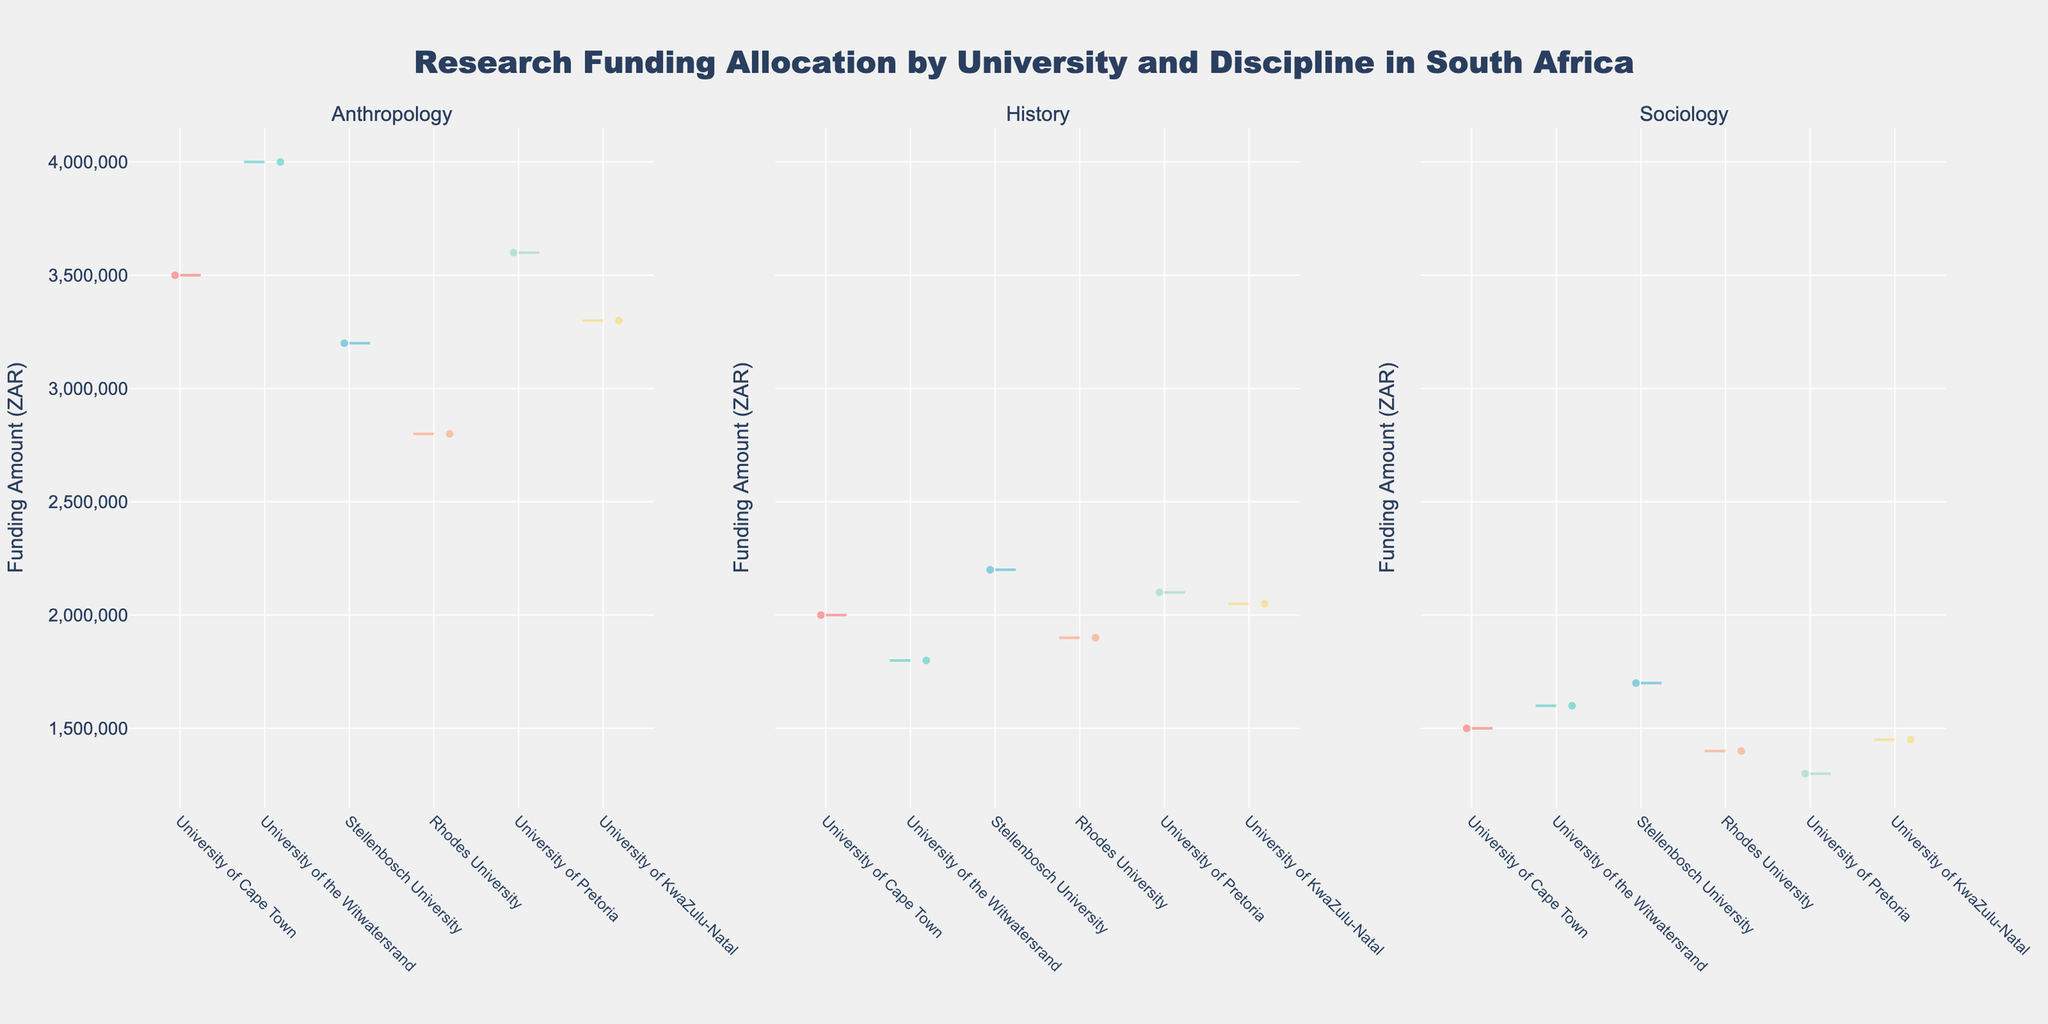What is the title of the figure? The title is generally located at the top of the figure. In this case, it reads 'Research Funding Allocation by University and Discipline in South Africa'.
Answer: Research Funding Allocation by University and Discipline in South Africa Which discipline appears to have the highest average funding allocation? To determine the discipline with the highest average funding, observe the violin plot and compare the widths of the distributions. The discipline with the widest distribution towards higher values indicates the highest average funding.
Answer: Anthropology Which university received the highest funding for Anthropology? Look at the appropriate segment within the Anthropology subplot and identify the university with the highest average or peak funding amount. This is represented by the peak of the violin plot.
Answer: University of Pretoria Are there any universities that received higher funding for History compared to Sociology? Compare the averages or peaks of the violin plots for History and Sociology for each university. Identify any universities where the History plot extends higher than the Sociology plot.
Answer: Yes (University of Pretoria, University of KwaZulu-Natal, Stellenbosch University) What is the funding range for Sociology at Rhodes University? Identify the section of the Sociology violin plot for Rhodes University. The range will extend from the minimum to the maximum value observed in the distribution.
Answer: 1,400,000 ZAR Which discipline has the most consistent funding allocations across universities? Consistency can be inferred by the narrowness and uniformity of the violin plots across all universities. The discipline with the least variation in plot width suggests consistent funding allocations.
Answer: Sociology How does the funding amount for History at Stellenbosch University compare to Anthropology at the University of Cape Town? Compare the peaks or average positions of the History violin plot at Stellenbosch University and the Anthropology plot at the University of Cape Town. This will show how one funding amount compares to the other.
Answer: Stellenbosch University has lower History funding compared to Anthropology at the University of Cape Town Is there any university that received more than 3,500,000 ZAR in two disciplines? Identify any universities that have peaks or distributions exceeding 3,500,000 ZAR in two or more subplots.
Answer: No Which university received the lowest funding for Sociology? Examine the Sociology subplot and find the university with the lowest point or smallest violin plot. This indicates the lowest funding allocation.
Answer: University of Pretoria What is the approximate funding difference between the highest and lowest funded universities for History? Observe the peaks of the History violin plots for the highest and lowest funded universities. Subtract the lowest peak from the highest peak to get the funding difference.
Answer: 400,000 ZAR 